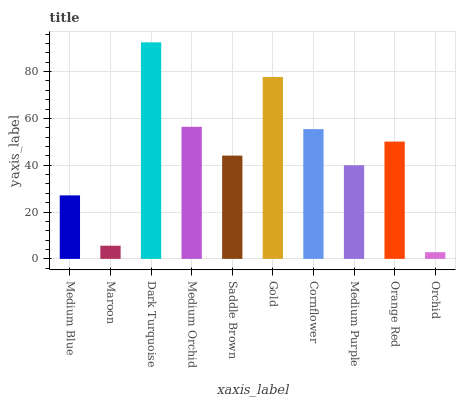Is Orchid the minimum?
Answer yes or no. Yes. Is Dark Turquoise the maximum?
Answer yes or no. Yes. Is Maroon the minimum?
Answer yes or no. No. Is Maroon the maximum?
Answer yes or no. No. Is Medium Blue greater than Maroon?
Answer yes or no. Yes. Is Maroon less than Medium Blue?
Answer yes or no. Yes. Is Maroon greater than Medium Blue?
Answer yes or no. No. Is Medium Blue less than Maroon?
Answer yes or no. No. Is Orange Red the high median?
Answer yes or no. Yes. Is Saddle Brown the low median?
Answer yes or no. Yes. Is Medium Purple the high median?
Answer yes or no. No. Is Orchid the low median?
Answer yes or no. No. 